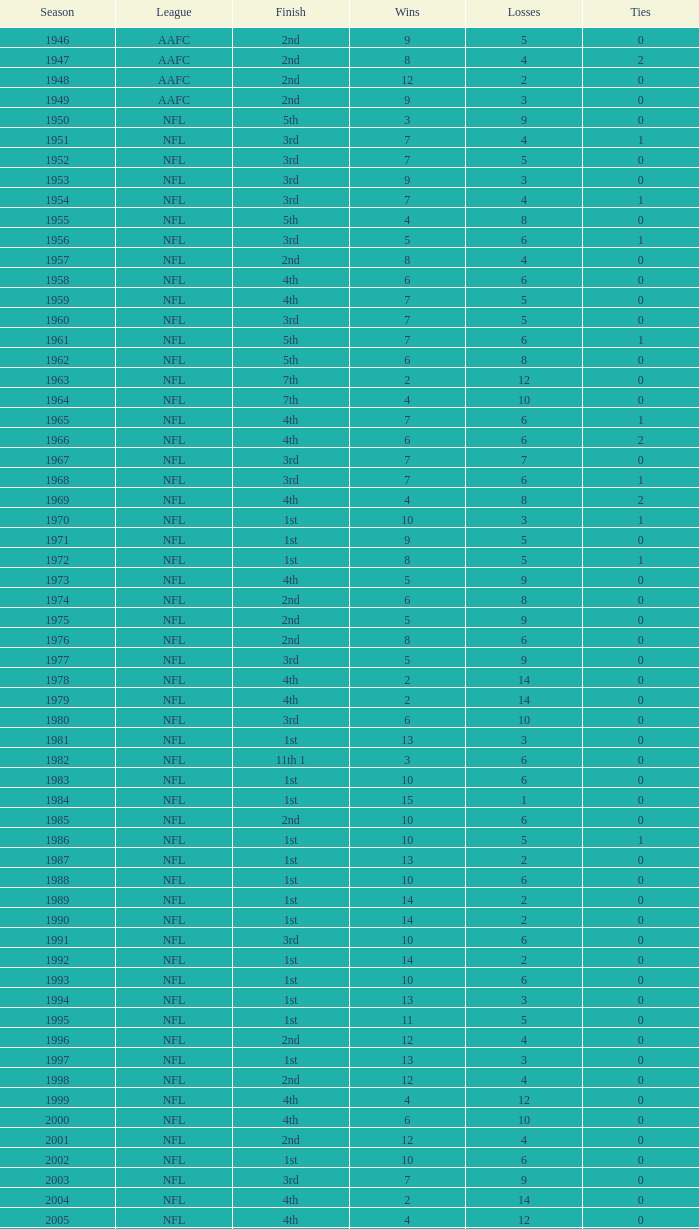What is the highest wins for the NFL with a finish of 1st, and more than 6 losses? None. 